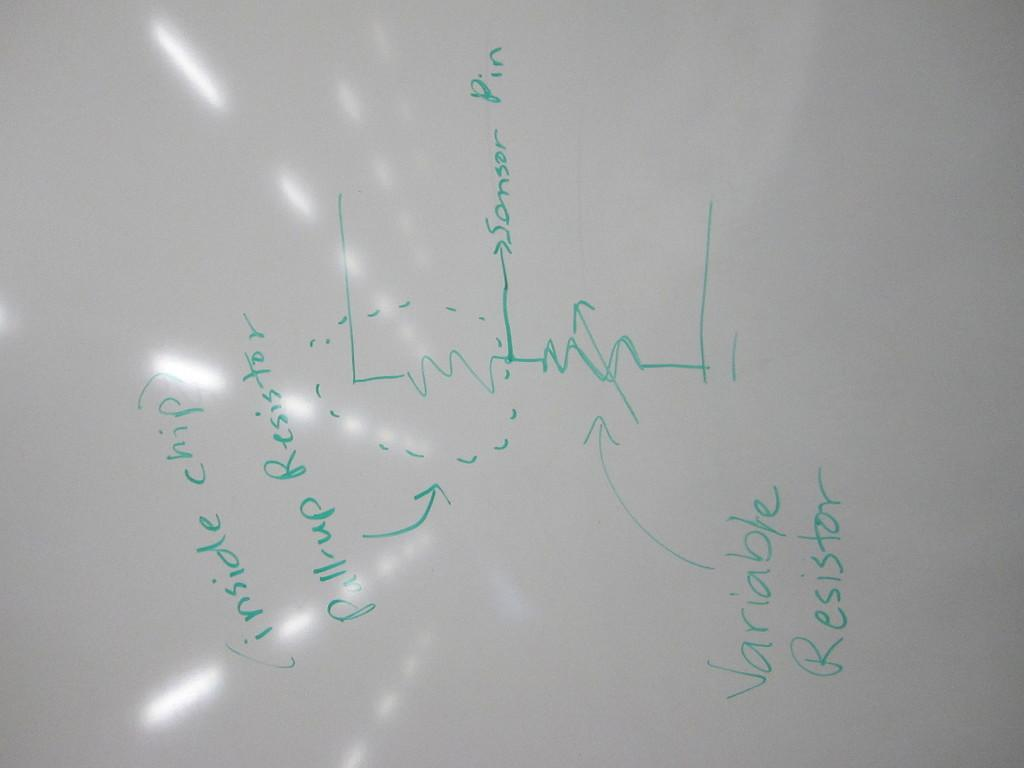What is present on the paper in the image? There is writing on a paper in the image. Can you describe the content of the writing? Unfortunately, the content of the writing cannot be determined from the image alone. Is the paper the only object in the image? The facts provided do not mention any other objects in the image, so we cannot definitively say whether there are other objects present. How many houses can be seen inside the hole in the image? There is no hole or houses present in the image; it only features writing on a paper. 